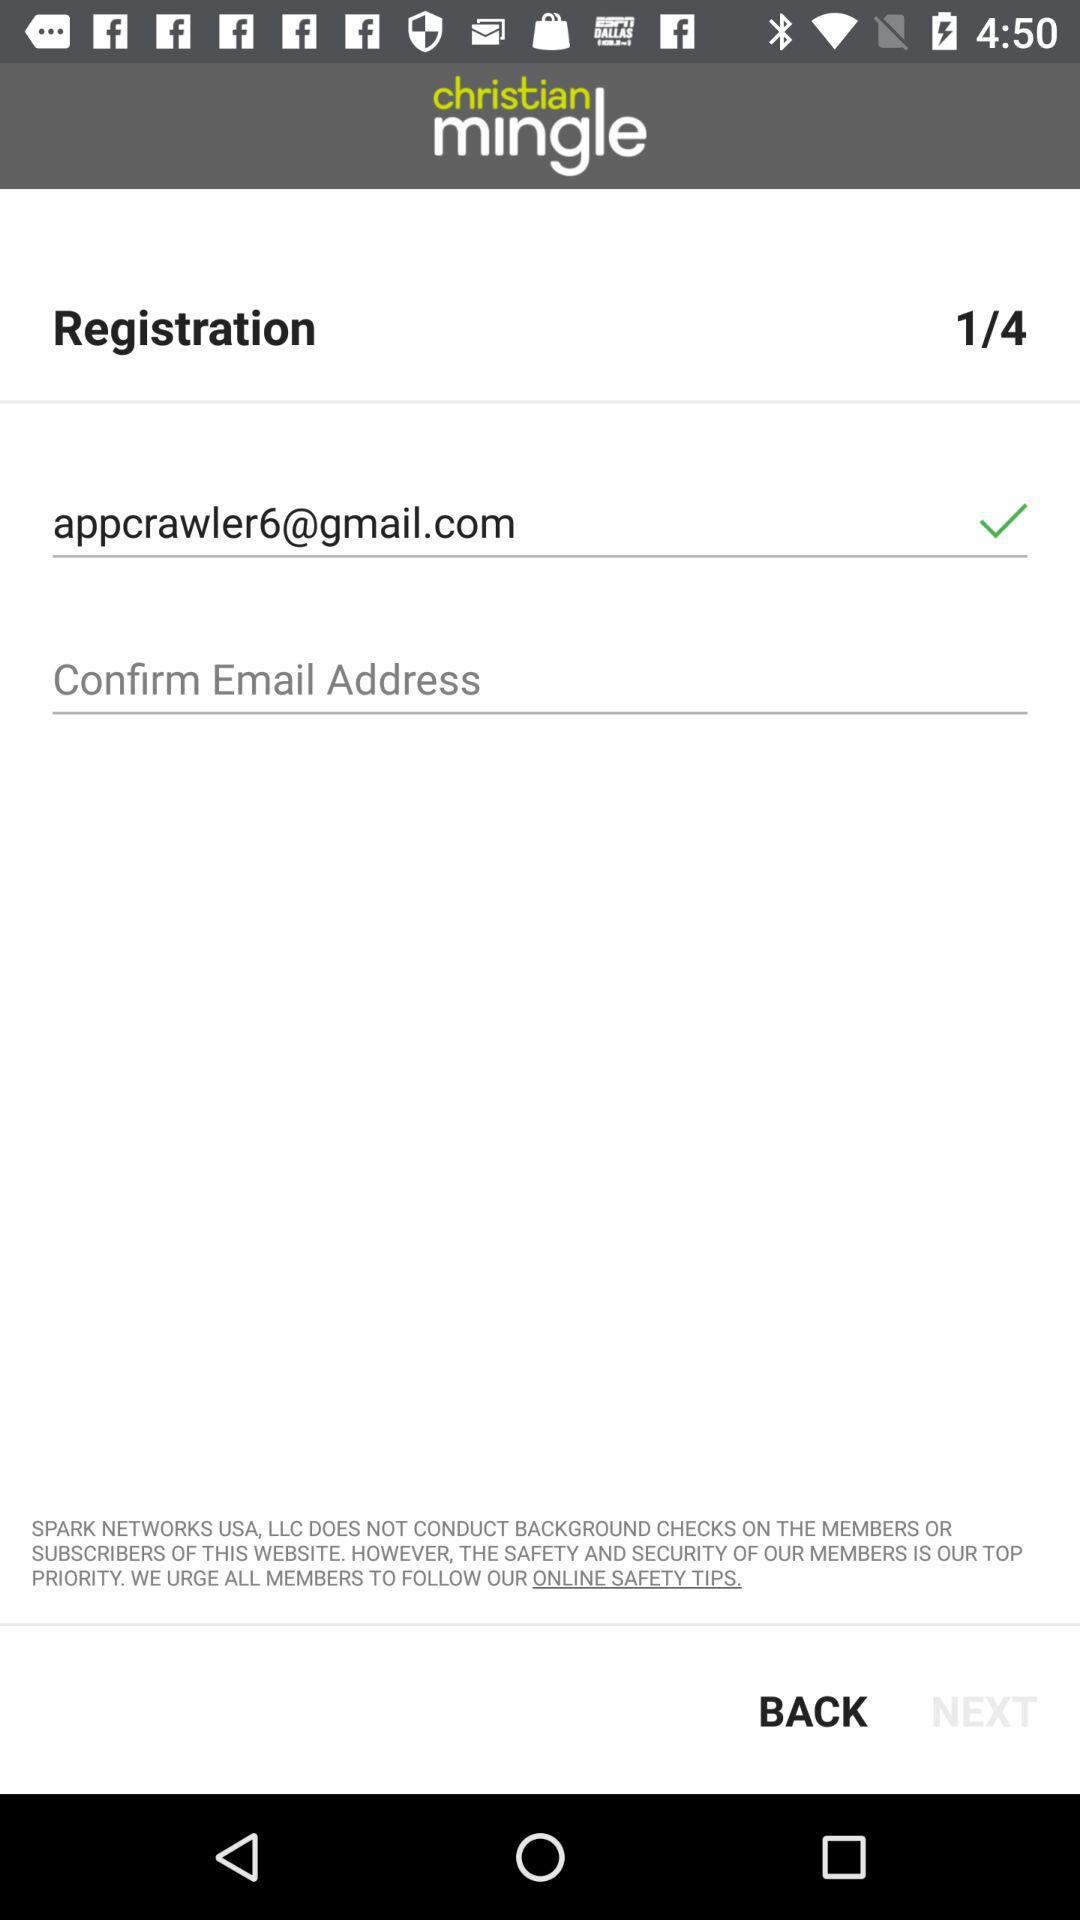How many text inputs have a check mark next to them?
Answer the question using a single word or phrase. 1 